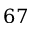Convert formula to latex. <formula><loc_0><loc_0><loc_500><loc_500>6 7</formula> 